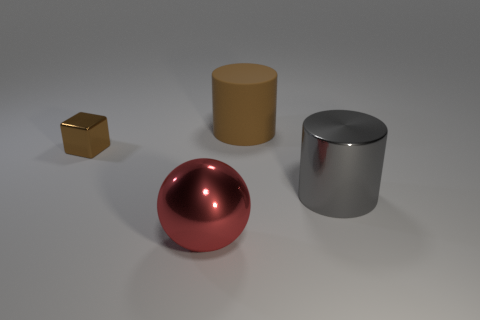Is there any other thing that has the same material as the big brown cylinder?
Offer a very short reply. No. What material is the brown object right of the metallic object that is in front of the big cylinder in front of the tiny brown object made of?
Provide a succinct answer. Rubber. How many objects are either big things that are left of the shiny cylinder or gray rubber cylinders?
Provide a short and direct response. 2. Do the big sphere and the rubber thing have the same color?
Give a very brief answer. No. There is a object on the left side of the large red object; what size is it?
Give a very brief answer. Small. Are there any brown matte blocks that have the same size as the red metal thing?
Give a very brief answer. No. There is a object in front of the metal cylinder; does it have the same size as the large brown cylinder?
Give a very brief answer. Yes. How big is the brown block?
Ensure brevity in your answer.  Small. There is a cylinder that is right of the large cylinder that is behind the cylinder in front of the shiny block; what is its color?
Make the answer very short. Gray. Does the big cylinder that is left of the large gray metallic object have the same color as the small shiny object?
Your answer should be very brief. Yes. 